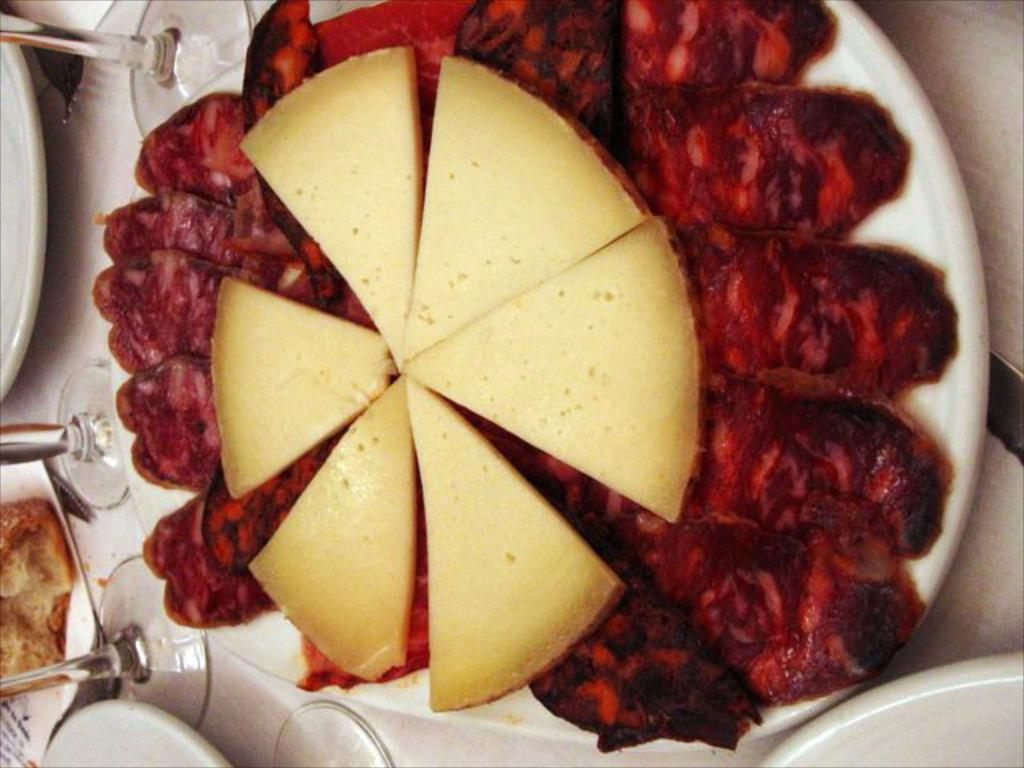What is on the plate that is visible in the image? There are food items on a plate in the image. How many plates are visible in the image? There are plates in the image. What type of utensil can be seen in the image? There is a fork in the image. What else is present in the image besides plates and food items? There are glasses in the image. What story is being told by the border of the plate in the image? There is no story being told by the border of the plate in the image, as it is not mentioned in the provided facts. What type of drink is being served in the glasses in the image? The provided facts do not specify what type of drink is being served in the glasses, so it cannot be determined from the image. 